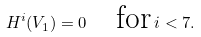Convert formula to latex. <formula><loc_0><loc_0><loc_500><loc_500>H ^ { i } ( V _ { 1 } ) = 0 \quad \text {for} \, i < 7 .</formula> 